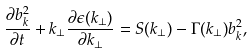Convert formula to latex. <formula><loc_0><loc_0><loc_500><loc_500>\frac { \partial b _ { k } ^ { 2 } } { \partial t } + k _ { \perp } \frac { \partial \epsilon ( k _ { \perp } ) } { \partial k _ { \perp } } = S ( k _ { \perp } ) - { \Gamma ( k _ { \perp } ) } b _ { k } ^ { 2 } ,</formula> 